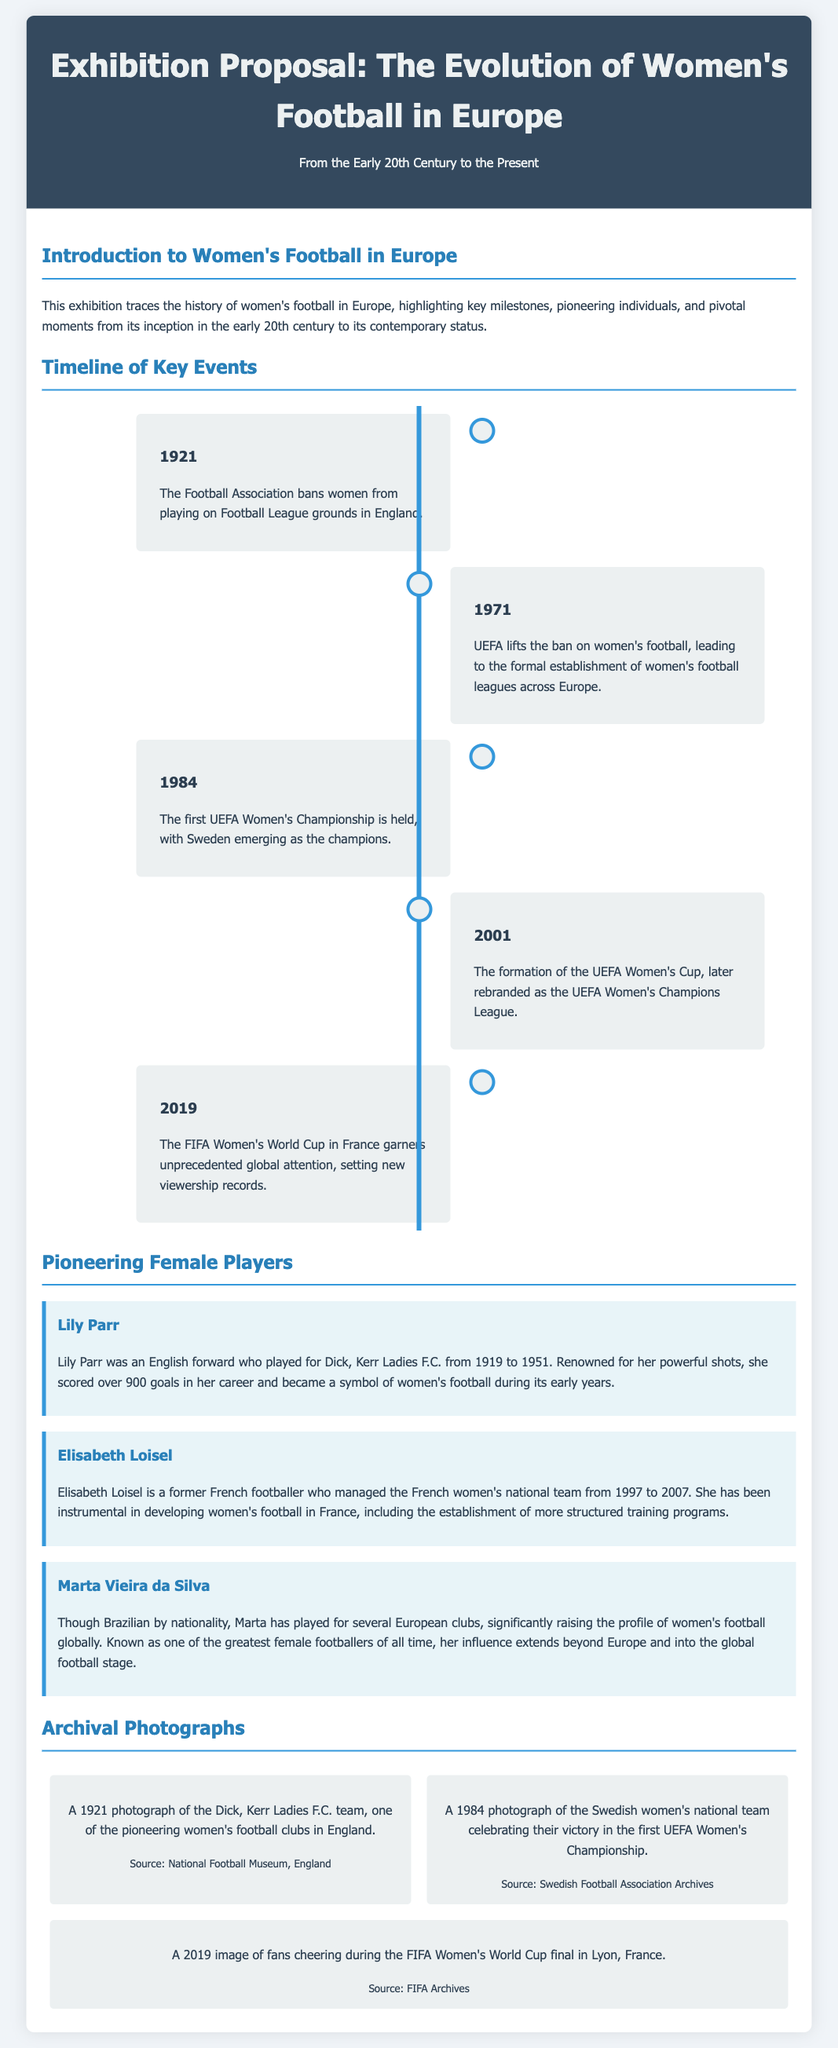What year did the Football Association ban women from playing on Football League grounds? The document states that the Football Association banned women from playing on Football League grounds in England in 1921.
Answer: 1921 Who won the first UEFA Women's Championship? According to the timeline, Sweden emerged as the champions of the first UEFA Women's Championship held in 1984.
Answer: Sweden What is the name of the player associated with Dick, Kerr Ladies F.C.? The document mentions Lily Parr as an English forward who played for Dick, Kerr Ladies F.C. from 1919 to 1951.
Answer: Lily Parr What significant event in women's football occurred in 2019? The timeline highlights that the FIFA Women's World Cup in France garnered unprecedented global attention in 2019.
Answer: FIFA Women's World Cup Which organization lifted the ban on women's football in 1971? The document specifies that UEFA lifted the ban on women's football in 1971.
Answer: UEFA What was Lily Parr known for? According to the document, Lily Parr was renowned for her powerful shots and scored over 900 goals during her career.
Answer: Powerful shots What type of photographs are included in the exhibition? The exhibition features archival photographs illustrating key moments in women's football history.
Answer: Archival photographs How long did Elisabeth Loisel manage the French women's national team? The document mentions that Elisabeth Loisel managed the French women's national team from 1997 to 2007, which is a span of 10 years.
Answer: 10 years Which notable female footballer was recognized as one of the greatest of all time? The document indicates that Marta Vieira da Silva is known as one of the greatest female footballers of all time.
Answer: Marta Vieira da Silva 